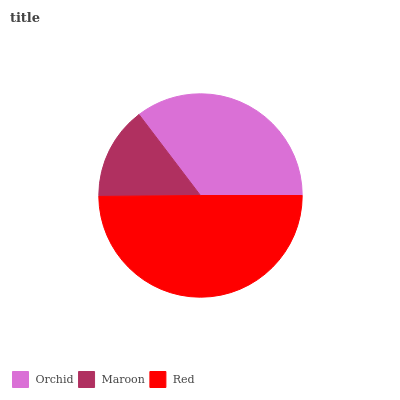Is Maroon the minimum?
Answer yes or no. Yes. Is Red the maximum?
Answer yes or no. Yes. Is Red the minimum?
Answer yes or no. No. Is Maroon the maximum?
Answer yes or no. No. Is Red greater than Maroon?
Answer yes or no. Yes. Is Maroon less than Red?
Answer yes or no. Yes. Is Maroon greater than Red?
Answer yes or no. No. Is Red less than Maroon?
Answer yes or no. No. Is Orchid the high median?
Answer yes or no. Yes. Is Orchid the low median?
Answer yes or no. Yes. Is Maroon the high median?
Answer yes or no. No. Is Maroon the low median?
Answer yes or no. No. 